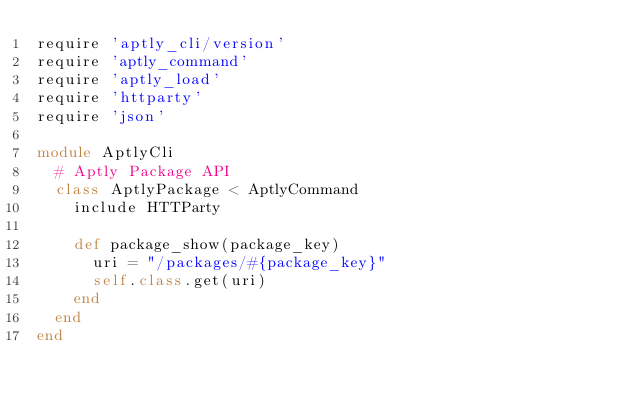<code> <loc_0><loc_0><loc_500><loc_500><_Ruby_>require 'aptly_cli/version'
require 'aptly_command'
require 'aptly_load'
require 'httparty'
require 'json'

module AptlyCli
  # Aptly Package API
  class AptlyPackage < AptlyCommand
    include HTTParty

    def package_show(package_key)
      uri = "/packages/#{package_key}"
      self.class.get(uri)
    end
  end
end
</code> 